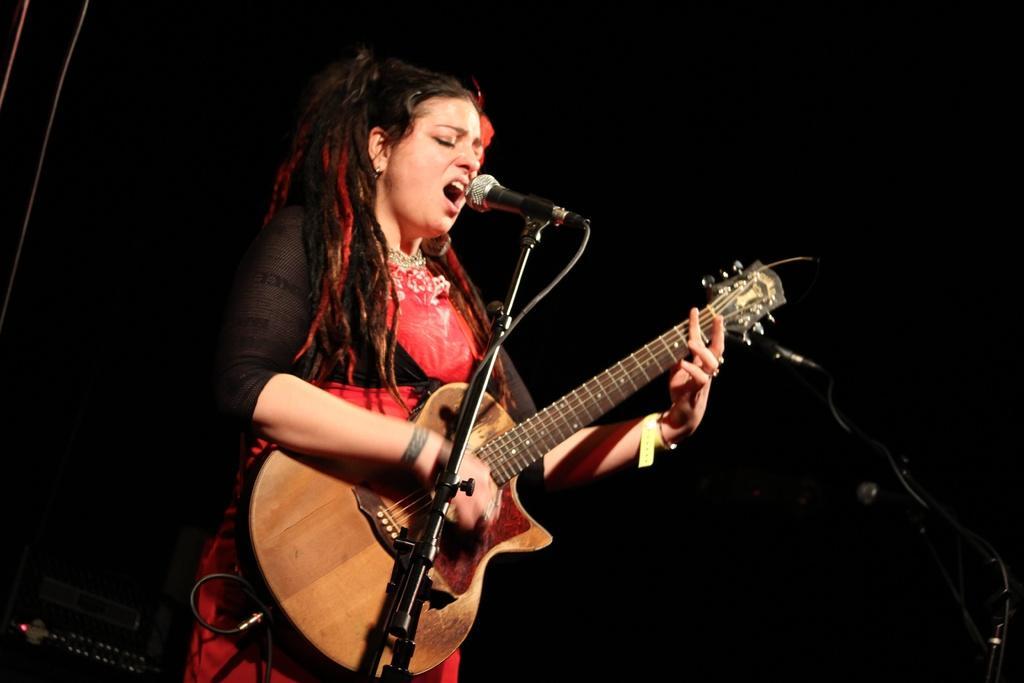Describe this image in one or two sentences. Here we can see a woman playing a guitar and singing a song with microphone in front of her 